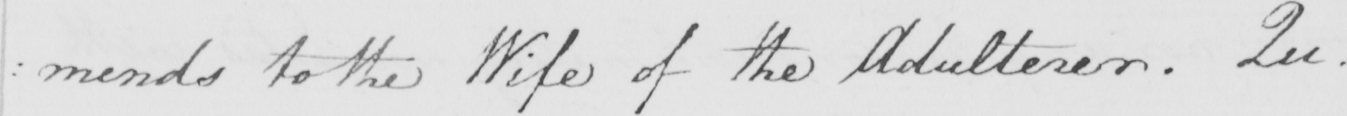What does this handwritten line say? : mends to the Wife of the Adulterer . Qu . 